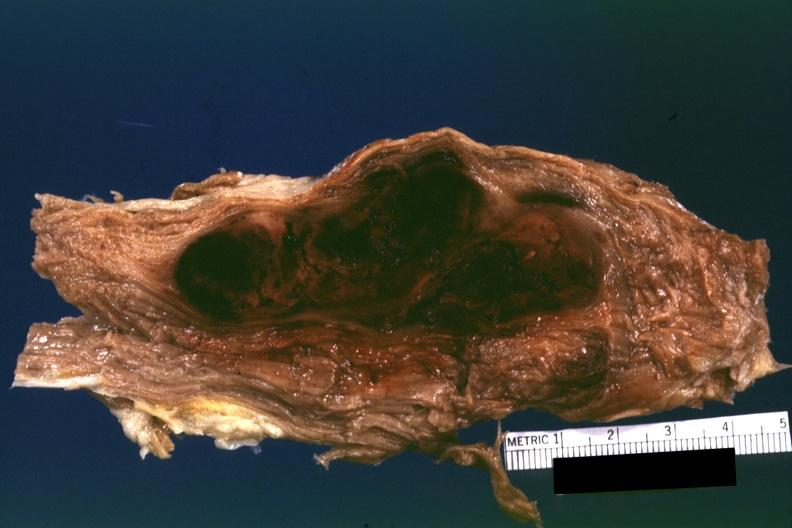what needs to be changed?
Answer the question using a single word or phrase. So the diagnosis on all other slides of this case in this file 